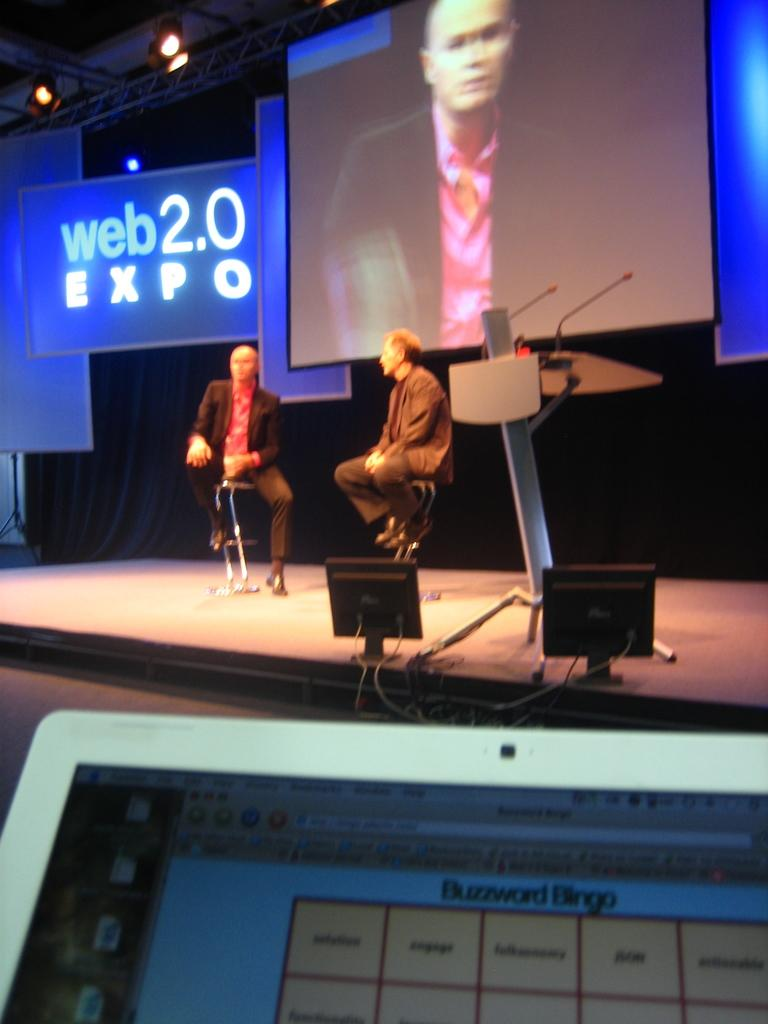<image>
Write a terse but informative summary of the picture. Someone in the crowd of web 2.0 expo is playing Buzzword Bingo. 